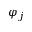Convert formula to latex. <formula><loc_0><loc_0><loc_500><loc_500>\varphi _ { j }</formula> 